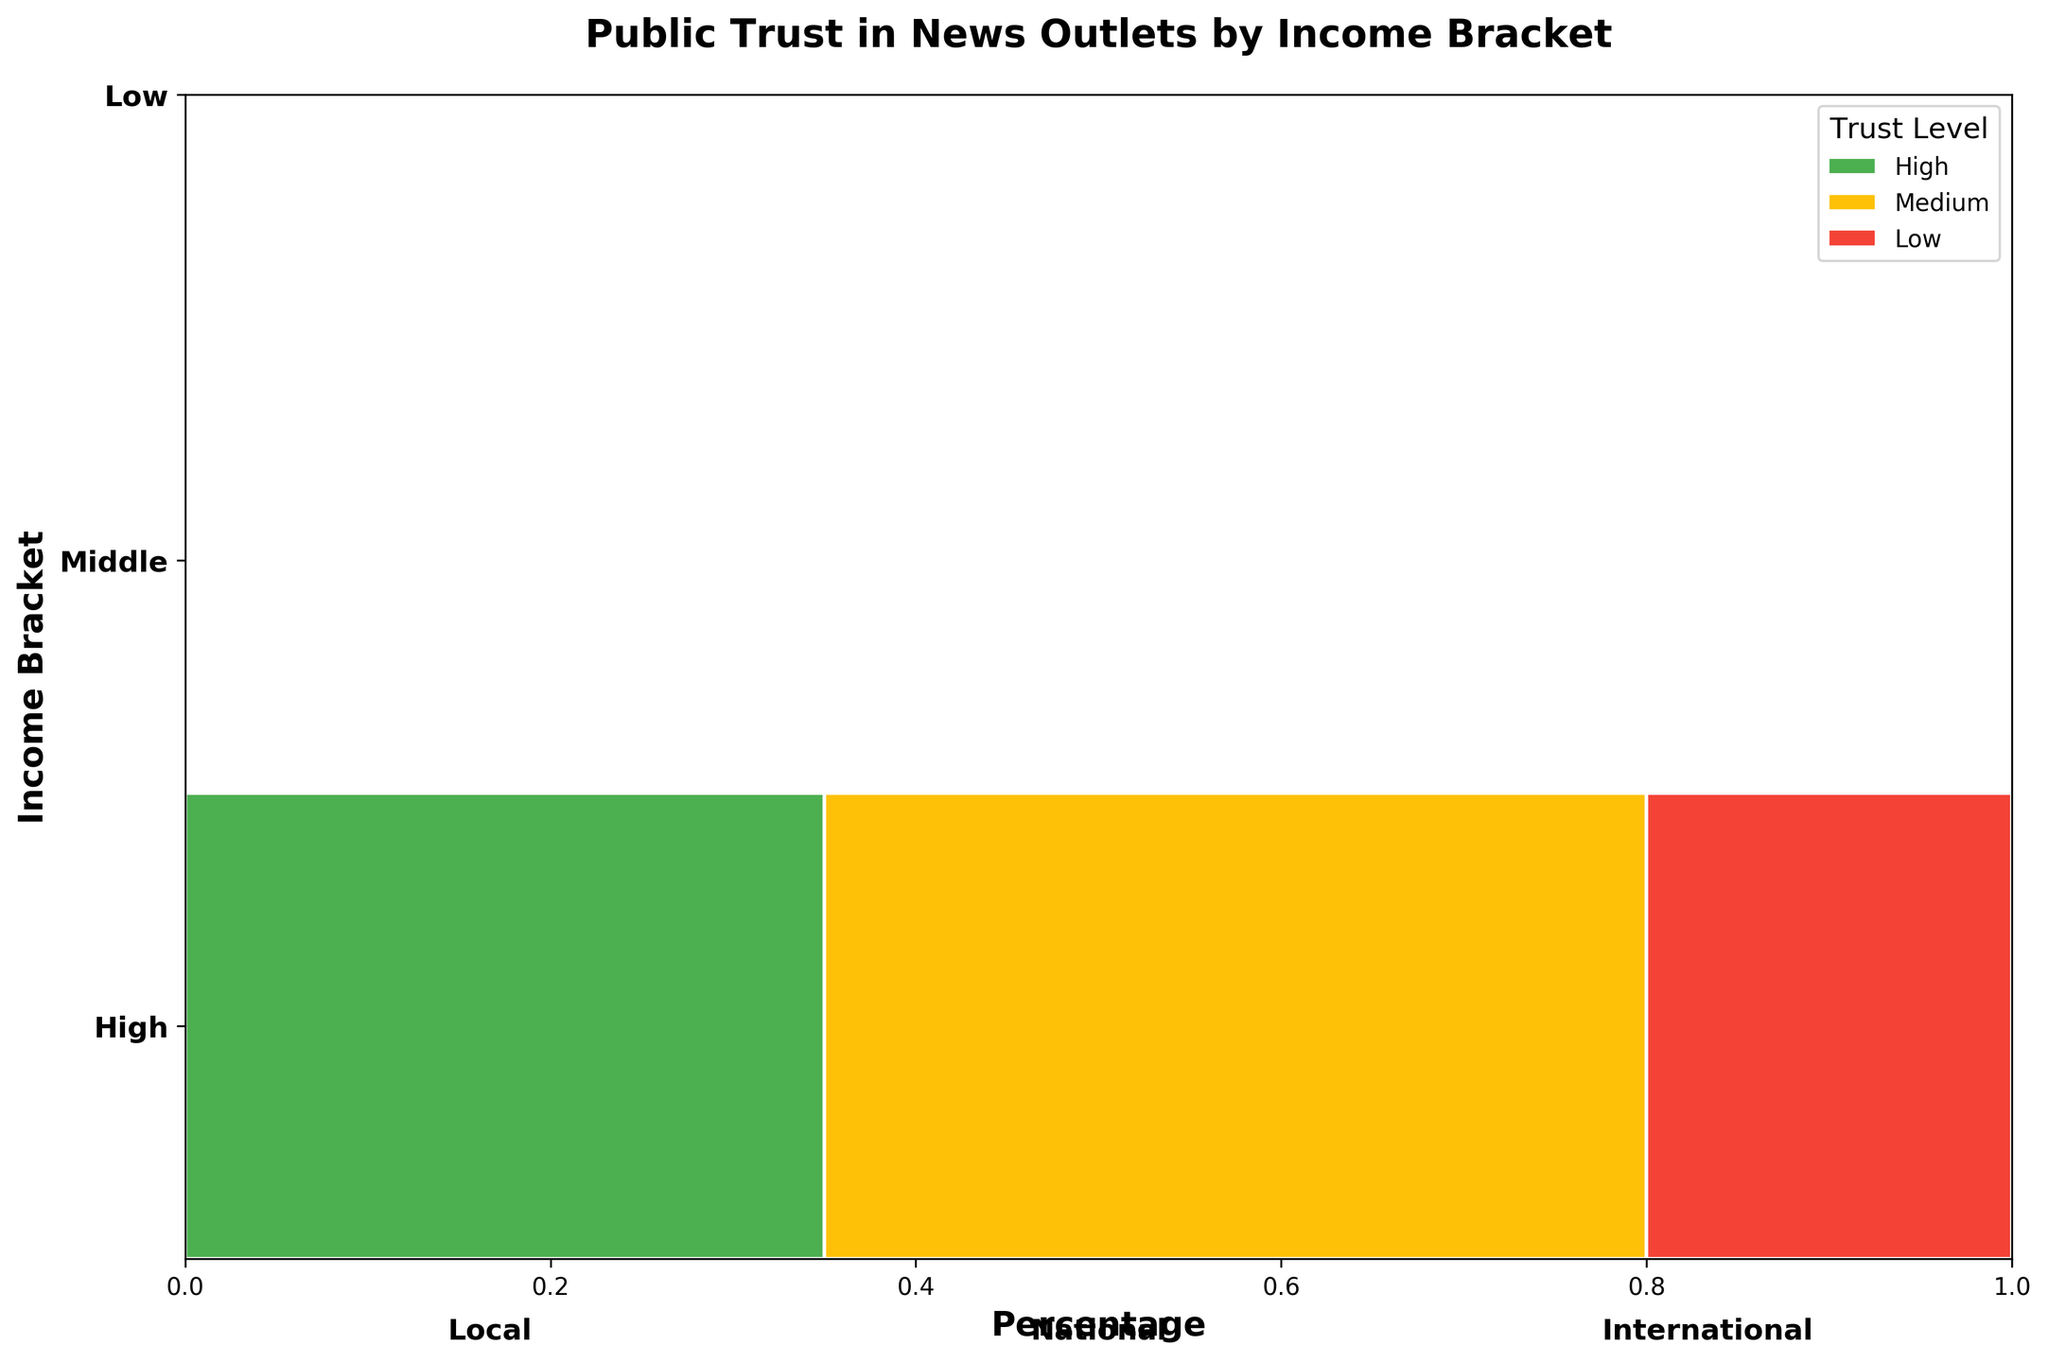What's the title of the plot? The title is usually displayed at the top of the plot and is intended to provide a quick summary of what the visualization represents. In this case, it reads "Public Trust in News Outlets by Income Bracket."
Answer: Public Trust in News Outlets by Income Bracket What are the three income brackets compared on the y-axis? The y-axis typically displays the categories being compared. In this plot, the y-axis labels indicate the income brackets, which are "Low," "Middle," and "High."
Answer: Low, Middle, High Which news type has the highest trust level for the high-income bracket? Look at the high-income bracket section and identify which news type has the largest green (high trust) rectangle. This would be the "Local" news type with a 45% trust level.
Answer: Local Among the low-income bracket, which news type has the lowest overall trust (sum of percentages for low trust)? For the low-income bracket, we sum the percentages of low trust for each news type. Local: 20%, National: 40%, International: 50%. International has the highest sum for low trust.
Answer: International What percentage of middle-income individuals have medium trust in international news? Find the section for middle-income and then locate the medium trust level (yellow) for international news. The percentage is mentioned as 40%.
Answer: 40% Compare the high trust levels for national news across all income brackets. Which bracket has the highest percentage? Look at the green (high trust) bars for national news in each income bracket: Low: 20%, Middle: 25%, High: 30%. The high-income bracket has the highest percentage.
Answer: High-income What's the difference in high trust percentage for local news between low and middle-income brackets? Refer to the percentages for high trust in local news: Low: 35%, Middle: 40%. The difference is 40% - 35% = 5%.
Answer: 5% Which income bracket shows the least variance in trust levels for local news? Examine the trust distribution for local news across each income bracket. Low has 35%/45%/20%, Middle has 40%/40%/20%, High has 45%/35%/20%. The middle-income bracket shows less variance as it has identical percentages for high and medium trust levels.
Answer: Middle Identify the news type with the most uniform trust distribution across all income brackets. Compare the distribution of trust levels for each news type across all income brackets. Local news in the middle-income bracket shows a consistent distribution: 40% high trust, 40% medium trust, and 20% low trust.
Answer: Local What percentage of high-income individuals have low trust in national news, and how does it compare to the low-income bracket? Locate the low trust level (red) for national news in both high and low-income brackets. High-income has 20%, and low-income has 40%. The high-income bracket has half the percentage of low trust compared to the low-income bracket.
Answer: High: 20%, Low: 40% 